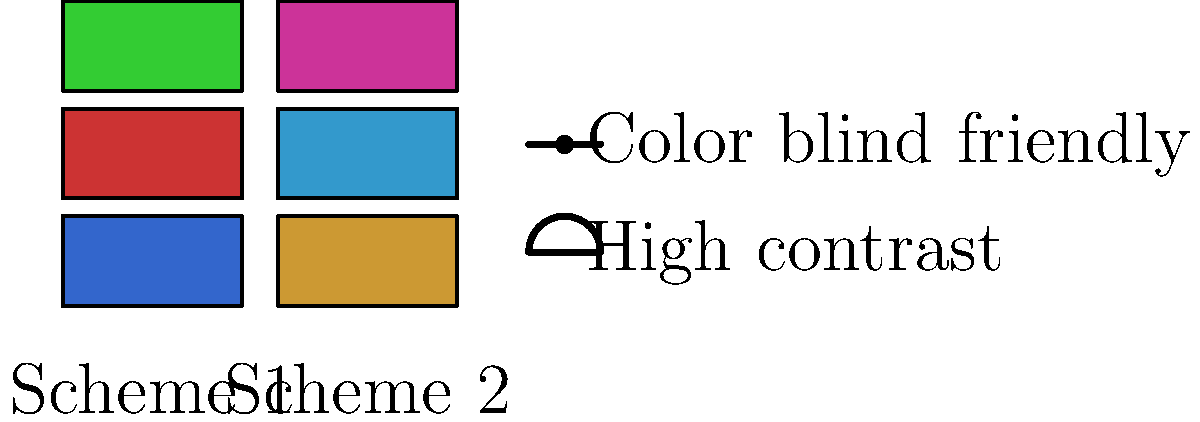As a UX designer specializing in accessibility, you are tasked with comparing two color schemes for an interface mockup. Scheme 1 uses blue, red, and green, while Scheme 2 uses orange, light blue, and purple. Which scheme is more suitable for colorblind users and why? To determine which color scheme is more suitable for colorblind users, we need to consider the following steps:

1. Understand color blindness:
   - The most common form is red-green color blindness.
   - Blue-yellow color blindness is less common but still significant.

2. Analyze Scheme 1 (blue, red, green):
   - This scheme uses primary colors.
   - Red and green are problematic for red-green colorblind users.
   - Blue is generally distinguishable for most colorblind individuals.

3. Analyze Scheme 2 (orange, light blue, purple):
   - This scheme uses more diverse hues.
   - Orange and light blue have different luminance values.
   - Purple is a mix of red and blue, which can be distinguished by most colorblind users.

4. Compare the schemes:
   - Scheme 1 relies heavily on red and green, which are difficult for many colorblind users to differentiate.
   - Scheme 2 uses colors with varying luminance and hues, making them easier to distinguish.

5. Consider contrast:
   - Scheme 2 appears to have better contrast between colors, which aids in distinguishing elements.

6. Evaluate overall accessibility:
   - Scheme 2 is more accessible due to its varied hues and luminance values.
   - It doesn't rely on problematic color combinations for colorblind users.

Therefore, Scheme 2 (orange, light blue, purple) is more suitable for colorblind users because it uses colors that are easier to distinguish and doesn't rely on problematic color combinations like red and green.
Answer: Scheme 2, due to varied hues and luminance, avoiding red-green combination. 